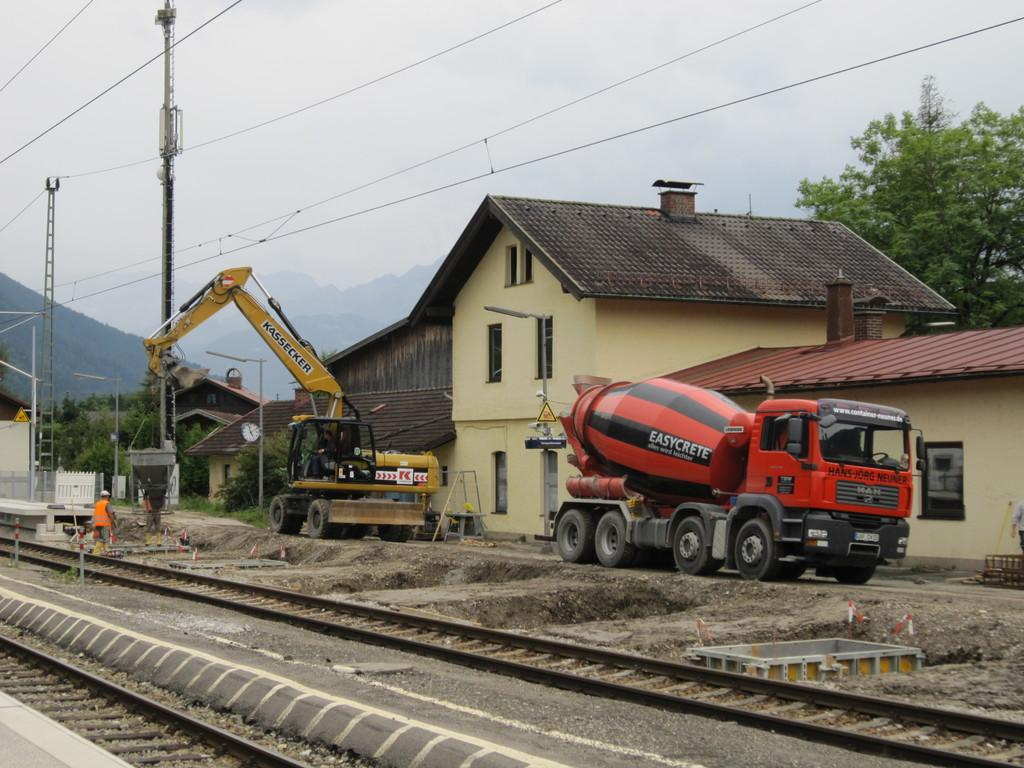<image>
Describe the image concisely. A construction site next to railway tracks is using an Easycrete concrete truck. 